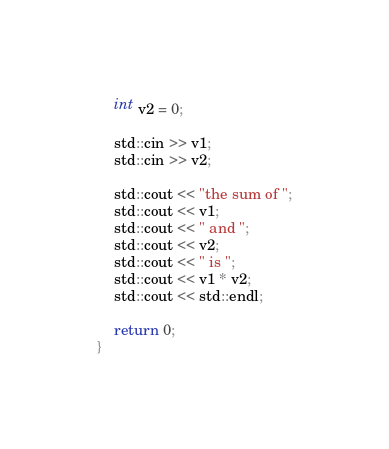<code> <loc_0><loc_0><loc_500><loc_500><_C++_>	int v2 = 0;

	std::cin >> v1;
	std::cin >> v2;

	std::cout << "the sum of ";
	std::cout << v1;
	std::cout << " and ";
	std::cout << v2;
	std::cout << " is ";
	std::cout << v1 * v2;
	std::cout << std::endl;

	return 0;
}
</code> 